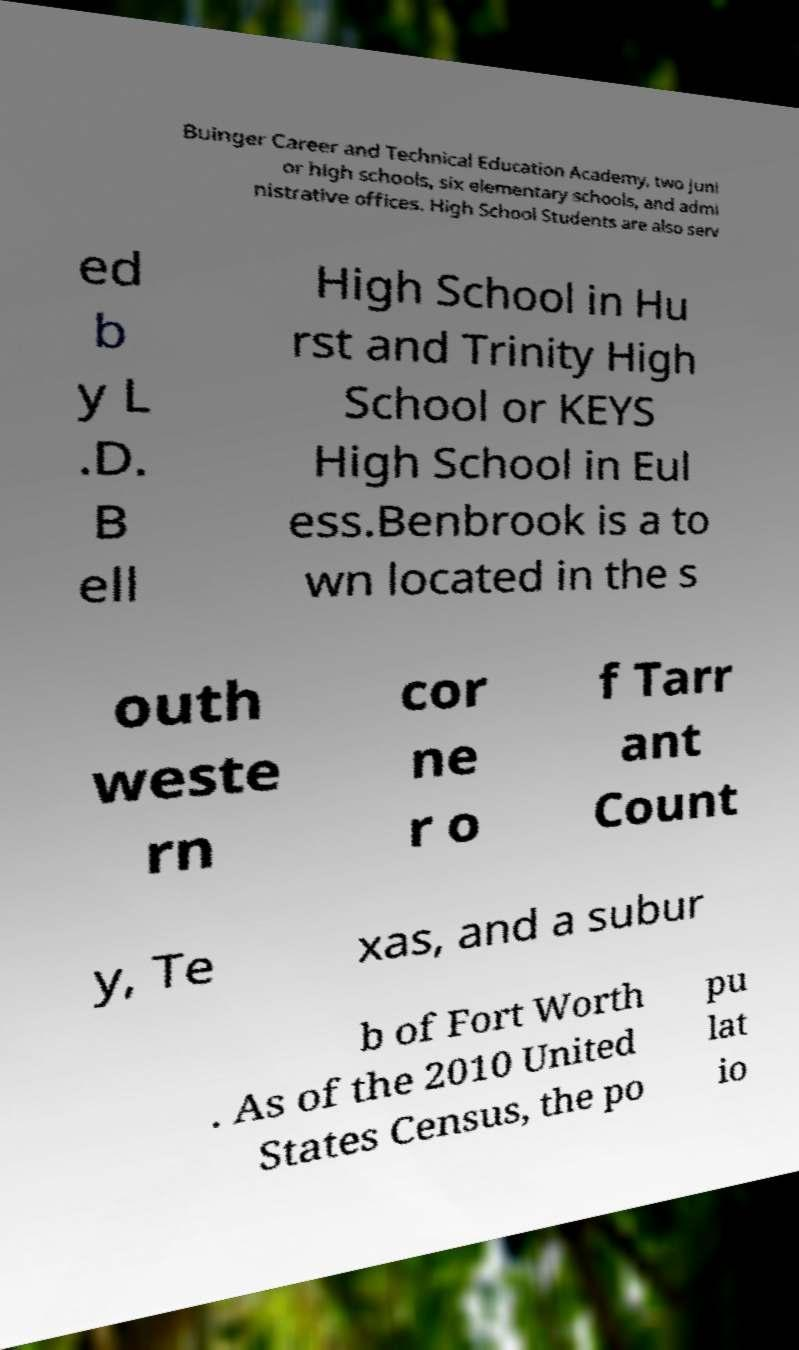What messages or text are displayed in this image? I need them in a readable, typed format. Buinger Career and Technical Education Academy, two juni or high schools, six elementary schools, and admi nistrative offices. High School Students are also serv ed b y L .D. B ell High School in Hu rst and Trinity High School or KEYS High School in Eul ess.Benbrook is a to wn located in the s outh weste rn cor ne r o f Tarr ant Count y, Te xas, and a subur b of Fort Worth . As of the 2010 United States Census, the po pu lat io 